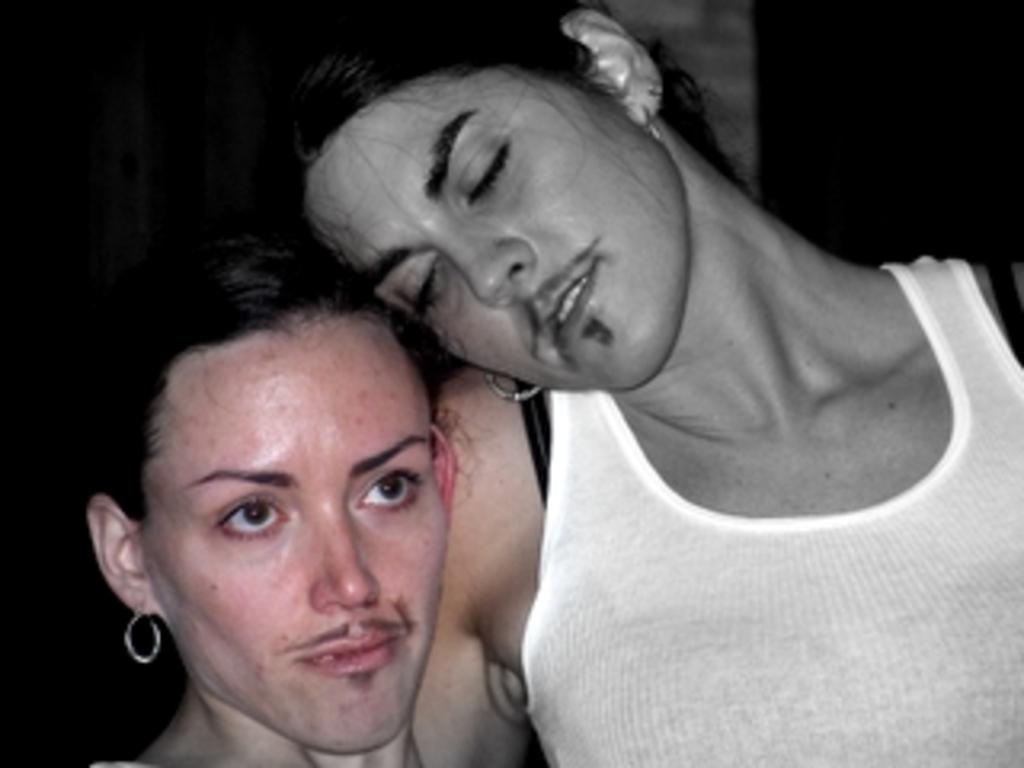How many people are in the image? There are two persons in the image. What can be observed about the background of the image? The background of the image is dark. What type of jeans is the person on the left wearing in the image? There is no information about the type of jeans or any clothing in the image, as the facts only mention the presence of two persons and a dark background. 